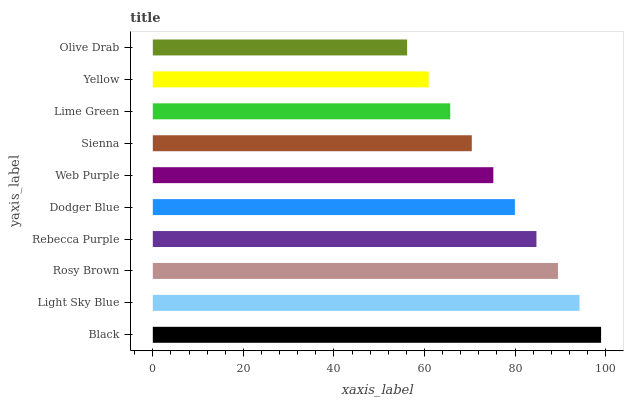Is Olive Drab the minimum?
Answer yes or no. Yes. Is Black the maximum?
Answer yes or no. Yes. Is Light Sky Blue the minimum?
Answer yes or no. No. Is Light Sky Blue the maximum?
Answer yes or no. No. Is Black greater than Light Sky Blue?
Answer yes or no. Yes. Is Light Sky Blue less than Black?
Answer yes or no. Yes. Is Light Sky Blue greater than Black?
Answer yes or no. No. Is Black less than Light Sky Blue?
Answer yes or no. No. Is Dodger Blue the high median?
Answer yes or no. Yes. Is Web Purple the low median?
Answer yes or no. Yes. Is Yellow the high median?
Answer yes or no. No. Is Rosy Brown the low median?
Answer yes or no. No. 